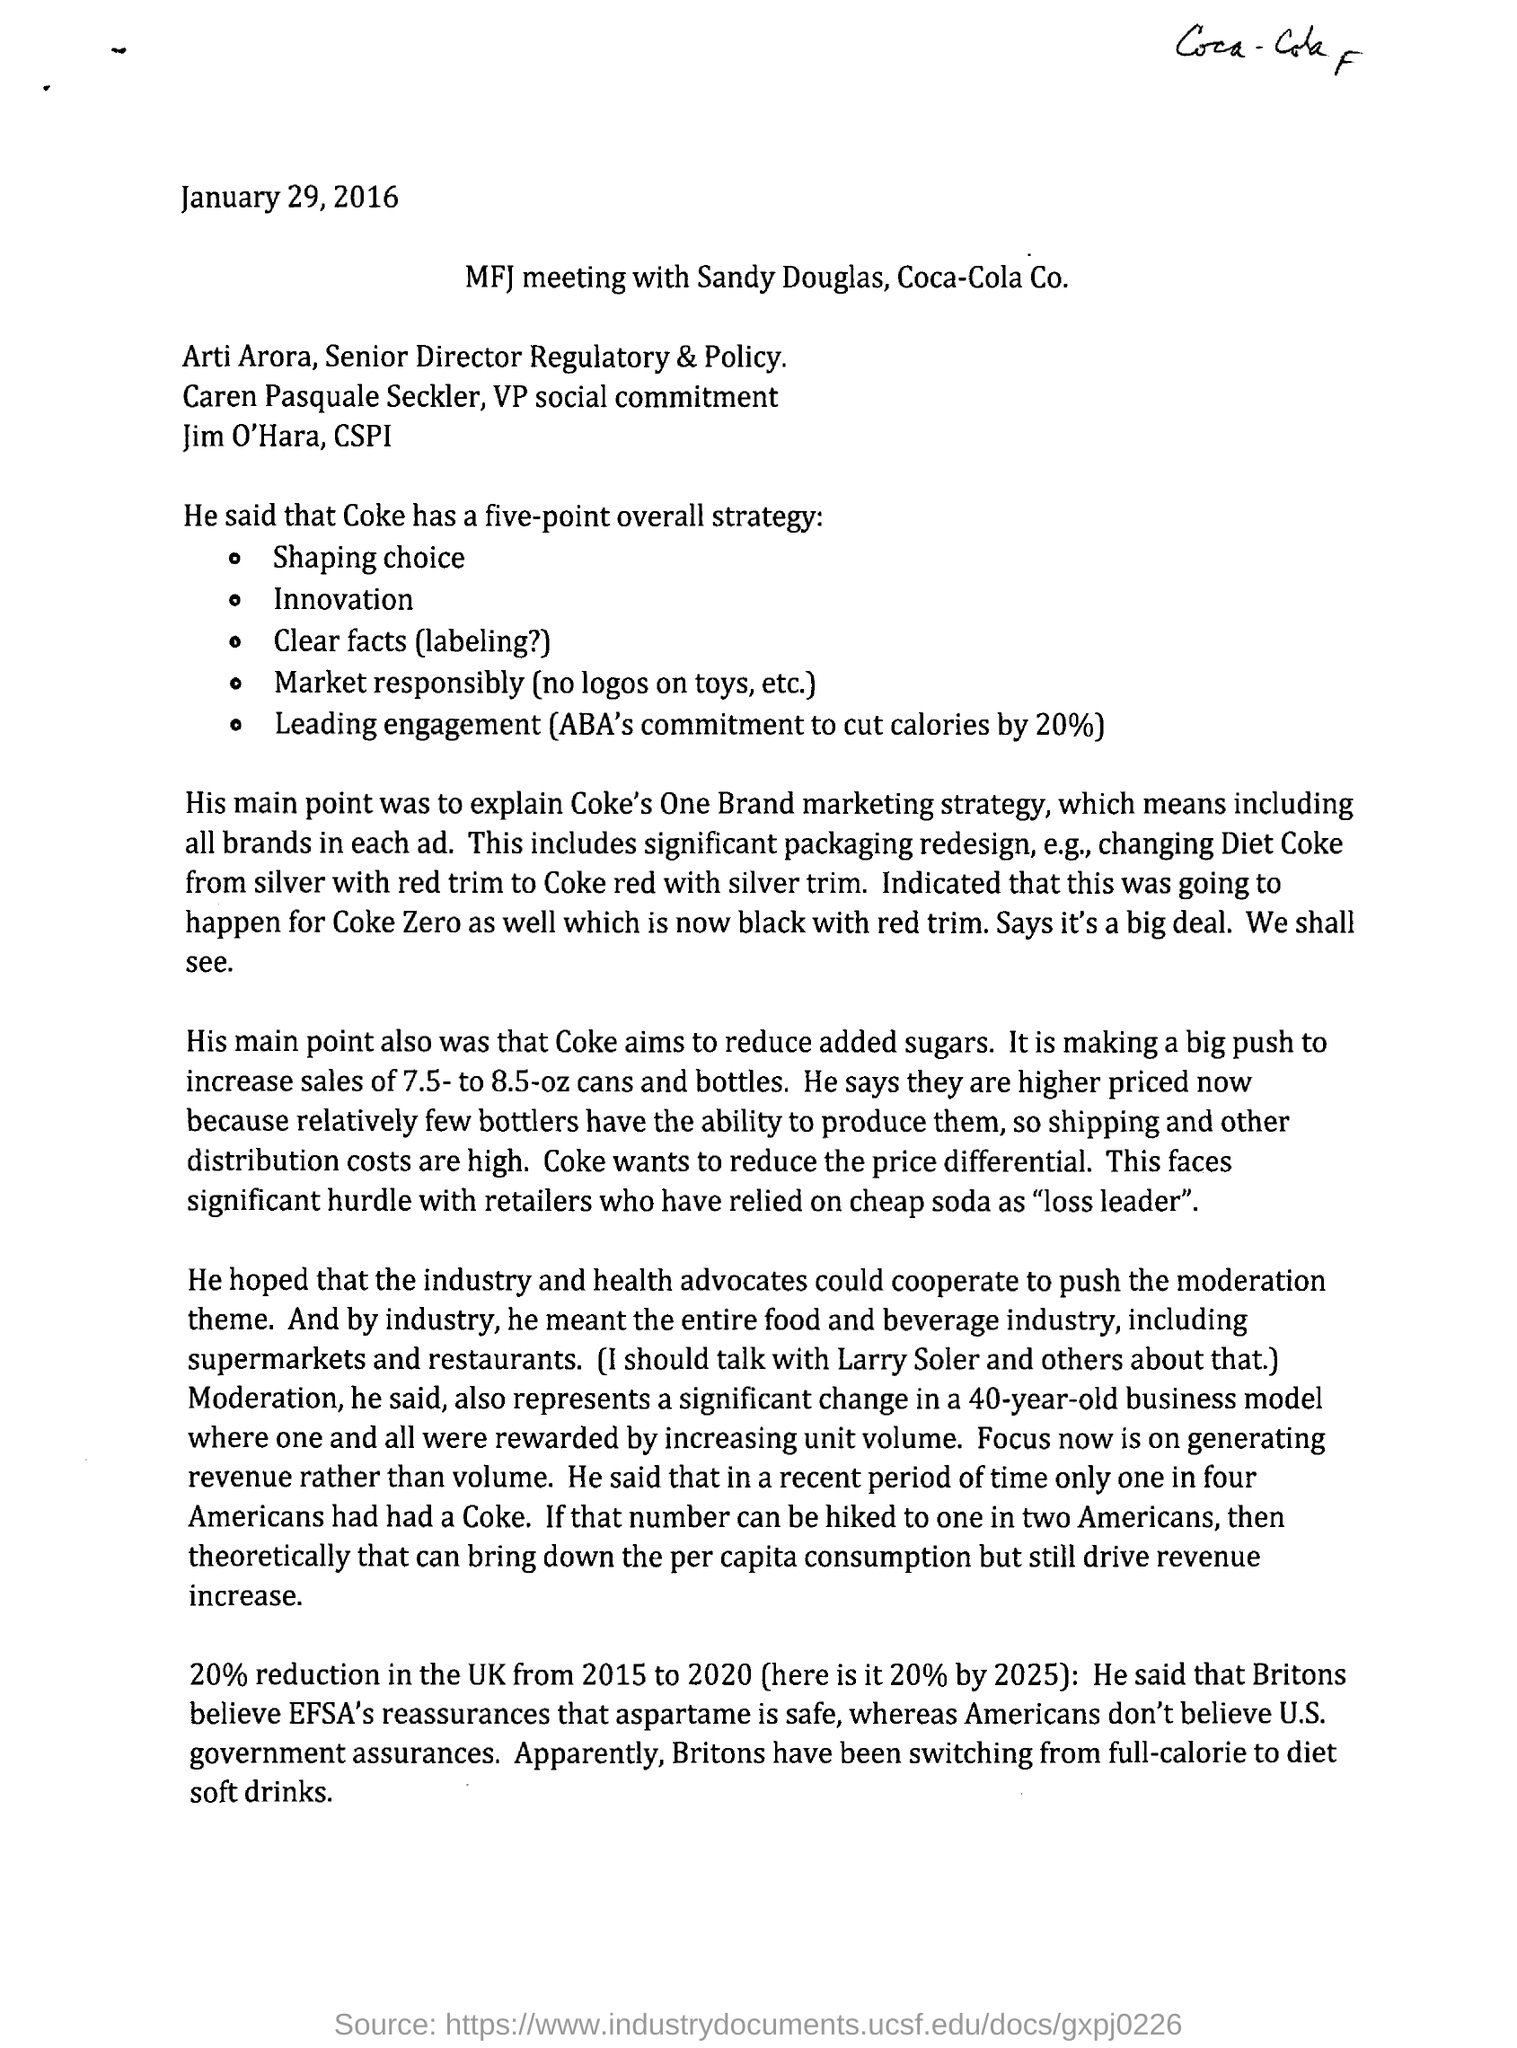Indicate a few pertinent items in this graphic. The meeting is being conducted by Sandy Douglas. The date mentioned in the header of the document is January 29, 2016. The date mentioned on the document is January 29, 2016. 